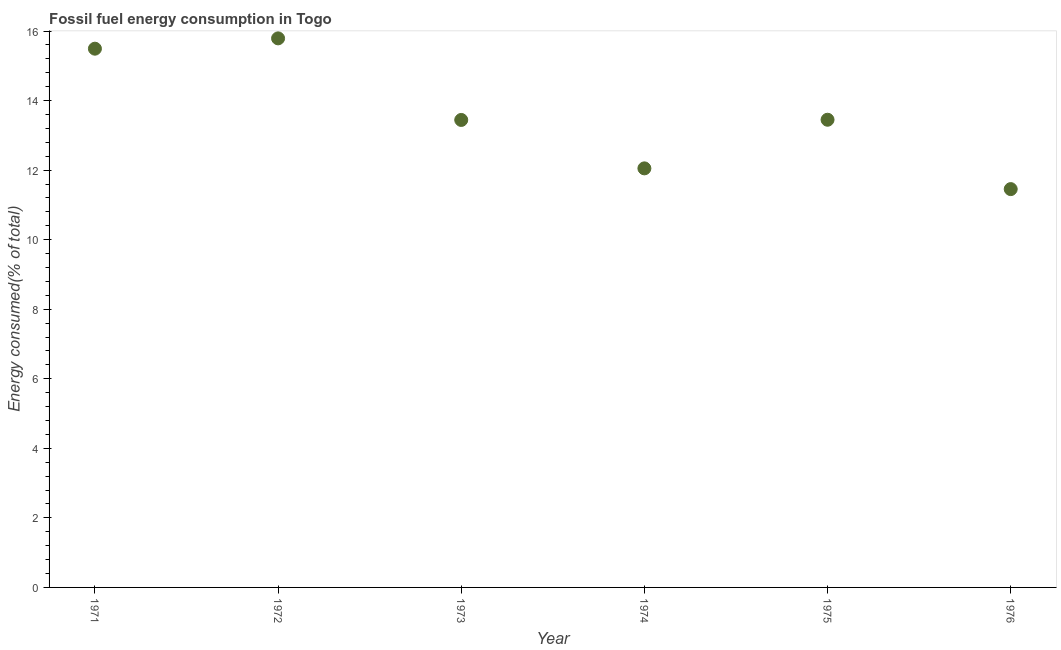What is the fossil fuel energy consumption in 1974?
Ensure brevity in your answer.  12.05. Across all years, what is the maximum fossil fuel energy consumption?
Make the answer very short. 15.79. Across all years, what is the minimum fossil fuel energy consumption?
Give a very brief answer. 11.45. In which year was the fossil fuel energy consumption minimum?
Keep it short and to the point. 1976. What is the sum of the fossil fuel energy consumption?
Offer a terse response. 81.68. What is the difference between the fossil fuel energy consumption in 1975 and 1976?
Offer a very short reply. 1.99. What is the average fossil fuel energy consumption per year?
Ensure brevity in your answer.  13.61. What is the median fossil fuel energy consumption?
Provide a succinct answer. 13.45. In how many years, is the fossil fuel energy consumption greater than 2 %?
Offer a terse response. 6. Do a majority of the years between 1976 and 1972 (inclusive) have fossil fuel energy consumption greater than 6 %?
Keep it short and to the point. Yes. What is the ratio of the fossil fuel energy consumption in 1973 to that in 1976?
Give a very brief answer. 1.17. Is the fossil fuel energy consumption in 1975 less than that in 1976?
Your answer should be compact. No. Is the difference between the fossil fuel energy consumption in 1971 and 1974 greater than the difference between any two years?
Provide a short and direct response. No. What is the difference between the highest and the second highest fossil fuel energy consumption?
Keep it short and to the point. 0.3. Is the sum of the fossil fuel energy consumption in 1972 and 1976 greater than the maximum fossil fuel energy consumption across all years?
Your answer should be very brief. Yes. What is the difference between the highest and the lowest fossil fuel energy consumption?
Give a very brief answer. 4.33. In how many years, is the fossil fuel energy consumption greater than the average fossil fuel energy consumption taken over all years?
Your answer should be very brief. 2. Does the fossil fuel energy consumption monotonically increase over the years?
Give a very brief answer. No. How many dotlines are there?
Your response must be concise. 1. Does the graph contain grids?
Provide a succinct answer. No. What is the title of the graph?
Your response must be concise. Fossil fuel energy consumption in Togo. What is the label or title of the Y-axis?
Offer a terse response. Energy consumed(% of total). What is the Energy consumed(% of total) in 1971?
Offer a very short reply. 15.49. What is the Energy consumed(% of total) in 1972?
Ensure brevity in your answer.  15.79. What is the Energy consumed(% of total) in 1973?
Give a very brief answer. 13.44. What is the Energy consumed(% of total) in 1974?
Give a very brief answer. 12.05. What is the Energy consumed(% of total) in 1975?
Provide a succinct answer. 13.45. What is the Energy consumed(% of total) in 1976?
Make the answer very short. 11.45. What is the difference between the Energy consumed(% of total) in 1971 and 1972?
Your response must be concise. -0.3. What is the difference between the Energy consumed(% of total) in 1971 and 1973?
Provide a short and direct response. 2.05. What is the difference between the Energy consumed(% of total) in 1971 and 1974?
Your answer should be very brief. 3.44. What is the difference between the Energy consumed(% of total) in 1971 and 1975?
Ensure brevity in your answer.  2.04. What is the difference between the Energy consumed(% of total) in 1971 and 1976?
Give a very brief answer. 4.04. What is the difference between the Energy consumed(% of total) in 1972 and 1973?
Your answer should be compact. 2.35. What is the difference between the Energy consumed(% of total) in 1972 and 1974?
Give a very brief answer. 3.74. What is the difference between the Energy consumed(% of total) in 1972 and 1975?
Offer a very short reply. 2.34. What is the difference between the Energy consumed(% of total) in 1972 and 1976?
Offer a very short reply. 4.33. What is the difference between the Energy consumed(% of total) in 1973 and 1974?
Give a very brief answer. 1.39. What is the difference between the Energy consumed(% of total) in 1973 and 1975?
Give a very brief answer. -0.01. What is the difference between the Energy consumed(% of total) in 1973 and 1976?
Offer a very short reply. 1.99. What is the difference between the Energy consumed(% of total) in 1974 and 1975?
Give a very brief answer. -1.4. What is the difference between the Energy consumed(% of total) in 1974 and 1976?
Offer a very short reply. 0.6. What is the difference between the Energy consumed(% of total) in 1975 and 1976?
Ensure brevity in your answer.  1.99. What is the ratio of the Energy consumed(% of total) in 1971 to that in 1973?
Make the answer very short. 1.15. What is the ratio of the Energy consumed(% of total) in 1971 to that in 1974?
Provide a short and direct response. 1.29. What is the ratio of the Energy consumed(% of total) in 1971 to that in 1975?
Ensure brevity in your answer.  1.15. What is the ratio of the Energy consumed(% of total) in 1971 to that in 1976?
Your answer should be compact. 1.35. What is the ratio of the Energy consumed(% of total) in 1972 to that in 1973?
Ensure brevity in your answer.  1.18. What is the ratio of the Energy consumed(% of total) in 1972 to that in 1974?
Your answer should be compact. 1.31. What is the ratio of the Energy consumed(% of total) in 1972 to that in 1975?
Give a very brief answer. 1.17. What is the ratio of the Energy consumed(% of total) in 1972 to that in 1976?
Provide a succinct answer. 1.38. What is the ratio of the Energy consumed(% of total) in 1973 to that in 1974?
Give a very brief answer. 1.12. What is the ratio of the Energy consumed(% of total) in 1973 to that in 1975?
Ensure brevity in your answer.  1. What is the ratio of the Energy consumed(% of total) in 1973 to that in 1976?
Provide a succinct answer. 1.17. What is the ratio of the Energy consumed(% of total) in 1974 to that in 1975?
Offer a very short reply. 0.9. What is the ratio of the Energy consumed(% of total) in 1974 to that in 1976?
Keep it short and to the point. 1.05. What is the ratio of the Energy consumed(% of total) in 1975 to that in 1976?
Your response must be concise. 1.17. 